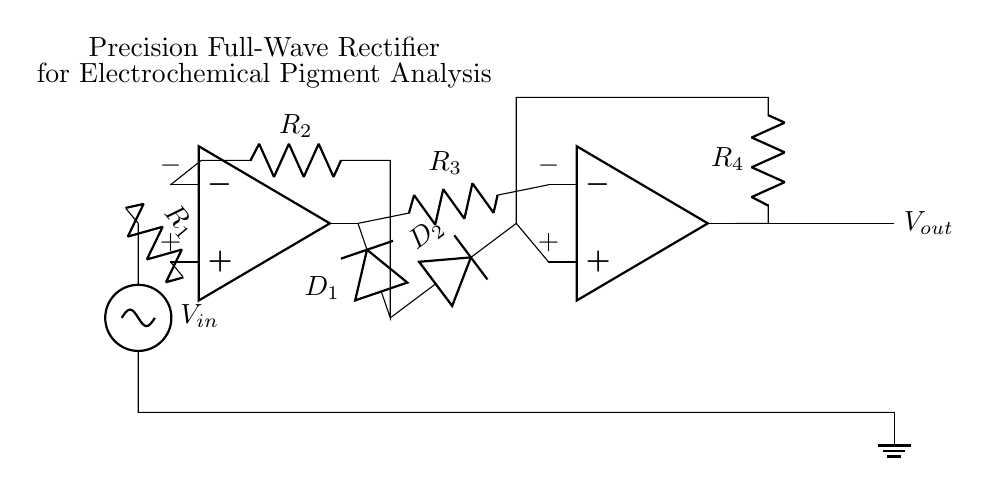What type of circuit is shown? The circuit is a full-wave rectifier, as it features two op-amps configured to rectify both the positive and negative portions of the input signal.
Answer: full-wave rectifier What components are used in the feedback loop of the first op-amp? The feedback loop of the first op-amp contains a resistor labeled R2 and a diode labeled D1. This configuration is typical for managing the input signal and establishing gain or feedback for the op-amp.
Answer: R2, D1 How many diodes are present in this circuit? There are two diodes in the circuit, namely D1 and D2, which are placed in the feedback paths of the two op-amps to allow current to pass in only one direction during the respective half-cycles of the input waveform.
Answer: 2 What is the purpose of resistors R3 and R4? Resistors R3 and R4 function primarily to limit the current and influence the gain of the output from the second op-amp. They are integral to setting the output characteristics of the precision rectifier, ensuring accurate current control.
Answer: Limit current, influence gain What is the voltage input labeled in the circuit? The input voltage is labeled as V in, which signifies the varying voltage signal that the rectifier circuit is designed to process for accurate current control in electrochemical analysis.
Answer: V in What role do the op-amps play in this circuit? The op-amps function as active components in this precision full-wave rectifier. They amplify the input signal and facilitate rectification by using feedback mechanisms and the connected diodes to control the output waveform accurately.
Answer: Amplification, rectification 